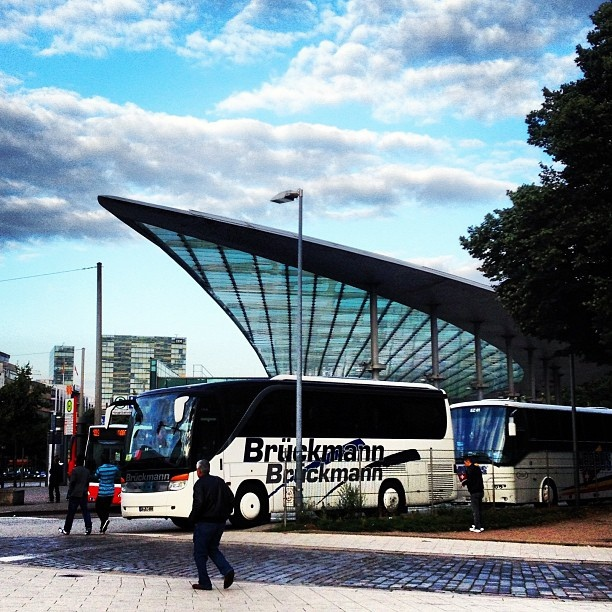Describe the objects in this image and their specific colors. I can see bus in lightblue, black, ivory, gray, and darkgray tones, bus in lightblue, black, navy, ivory, and gray tones, people in lightblue, black, gray, and maroon tones, people in lightblue, black, gray, darkgray, and lavender tones, and bus in lightblue, black, gray, white, and darkgray tones in this image. 